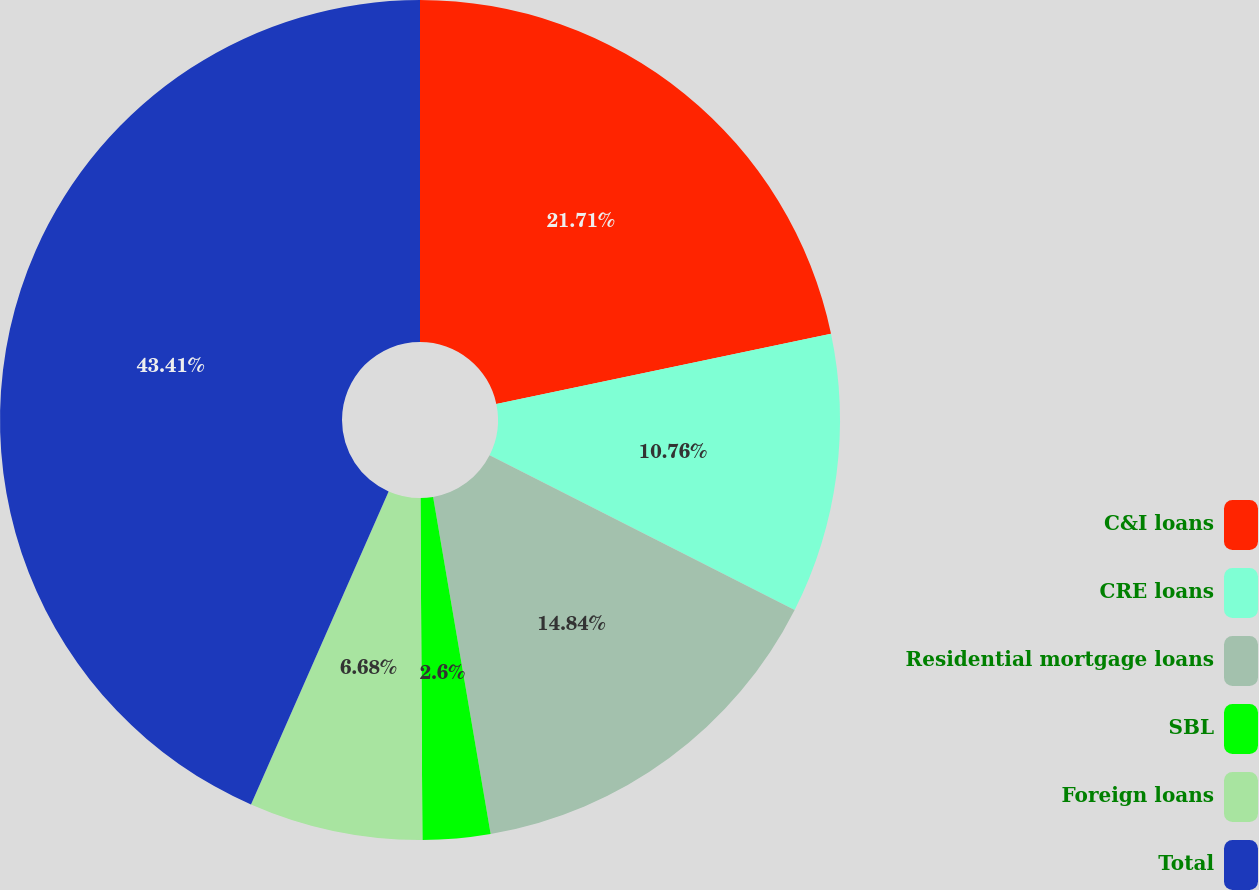<chart> <loc_0><loc_0><loc_500><loc_500><pie_chart><fcel>C&I loans<fcel>CRE loans<fcel>Residential mortgage loans<fcel>SBL<fcel>Foreign loans<fcel>Total<nl><fcel>21.7%<fcel>10.76%<fcel>14.84%<fcel>2.6%<fcel>6.68%<fcel>43.4%<nl></chart> 